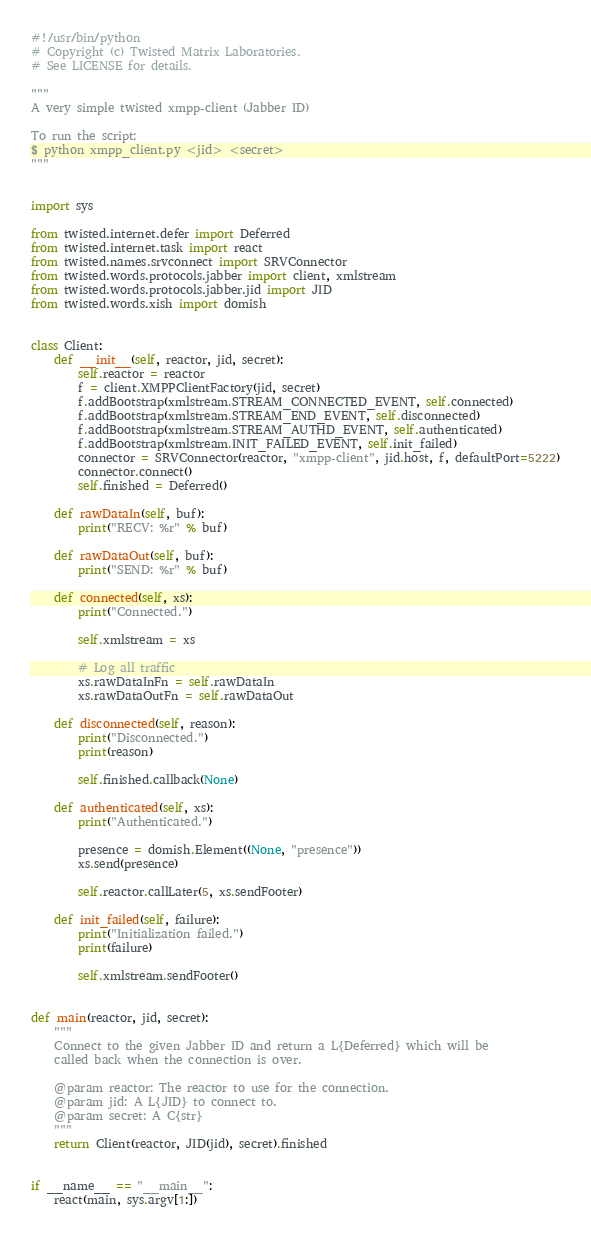<code> <loc_0><loc_0><loc_500><loc_500><_Python_>#!/usr/bin/python
# Copyright (c) Twisted Matrix Laboratories.
# See LICENSE for details.

"""
A very simple twisted xmpp-client (Jabber ID)

To run the script:
$ python xmpp_client.py <jid> <secret>
"""


import sys

from twisted.internet.defer import Deferred
from twisted.internet.task import react
from twisted.names.srvconnect import SRVConnector
from twisted.words.protocols.jabber import client, xmlstream
from twisted.words.protocols.jabber.jid import JID
from twisted.words.xish import domish


class Client:
    def __init__(self, reactor, jid, secret):
        self.reactor = reactor
        f = client.XMPPClientFactory(jid, secret)
        f.addBootstrap(xmlstream.STREAM_CONNECTED_EVENT, self.connected)
        f.addBootstrap(xmlstream.STREAM_END_EVENT, self.disconnected)
        f.addBootstrap(xmlstream.STREAM_AUTHD_EVENT, self.authenticated)
        f.addBootstrap(xmlstream.INIT_FAILED_EVENT, self.init_failed)
        connector = SRVConnector(reactor, "xmpp-client", jid.host, f, defaultPort=5222)
        connector.connect()
        self.finished = Deferred()

    def rawDataIn(self, buf):
        print("RECV: %r" % buf)

    def rawDataOut(self, buf):
        print("SEND: %r" % buf)

    def connected(self, xs):
        print("Connected.")

        self.xmlstream = xs

        # Log all traffic
        xs.rawDataInFn = self.rawDataIn
        xs.rawDataOutFn = self.rawDataOut

    def disconnected(self, reason):
        print("Disconnected.")
        print(reason)

        self.finished.callback(None)

    def authenticated(self, xs):
        print("Authenticated.")

        presence = domish.Element((None, "presence"))
        xs.send(presence)

        self.reactor.callLater(5, xs.sendFooter)

    def init_failed(self, failure):
        print("Initialization failed.")
        print(failure)

        self.xmlstream.sendFooter()


def main(reactor, jid, secret):
    """
    Connect to the given Jabber ID and return a L{Deferred} which will be
    called back when the connection is over.

    @param reactor: The reactor to use for the connection.
    @param jid: A L{JID} to connect to.
    @param secret: A C{str}
    """
    return Client(reactor, JID(jid), secret).finished


if __name__ == "__main__":
    react(main, sys.argv[1:])
</code> 